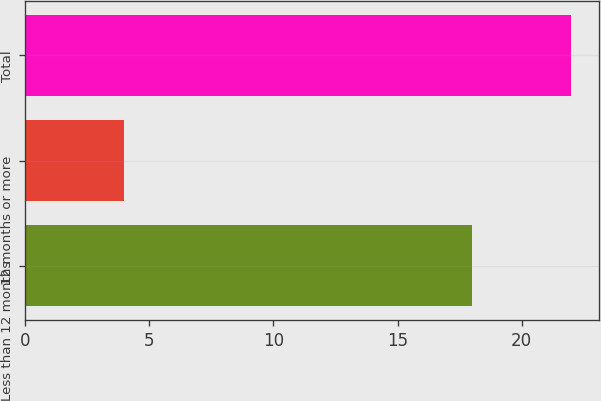<chart> <loc_0><loc_0><loc_500><loc_500><bar_chart><fcel>Less than 12 months<fcel>12 months or more<fcel>Total<nl><fcel>18<fcel>4<fcel>22<nl></chart> 